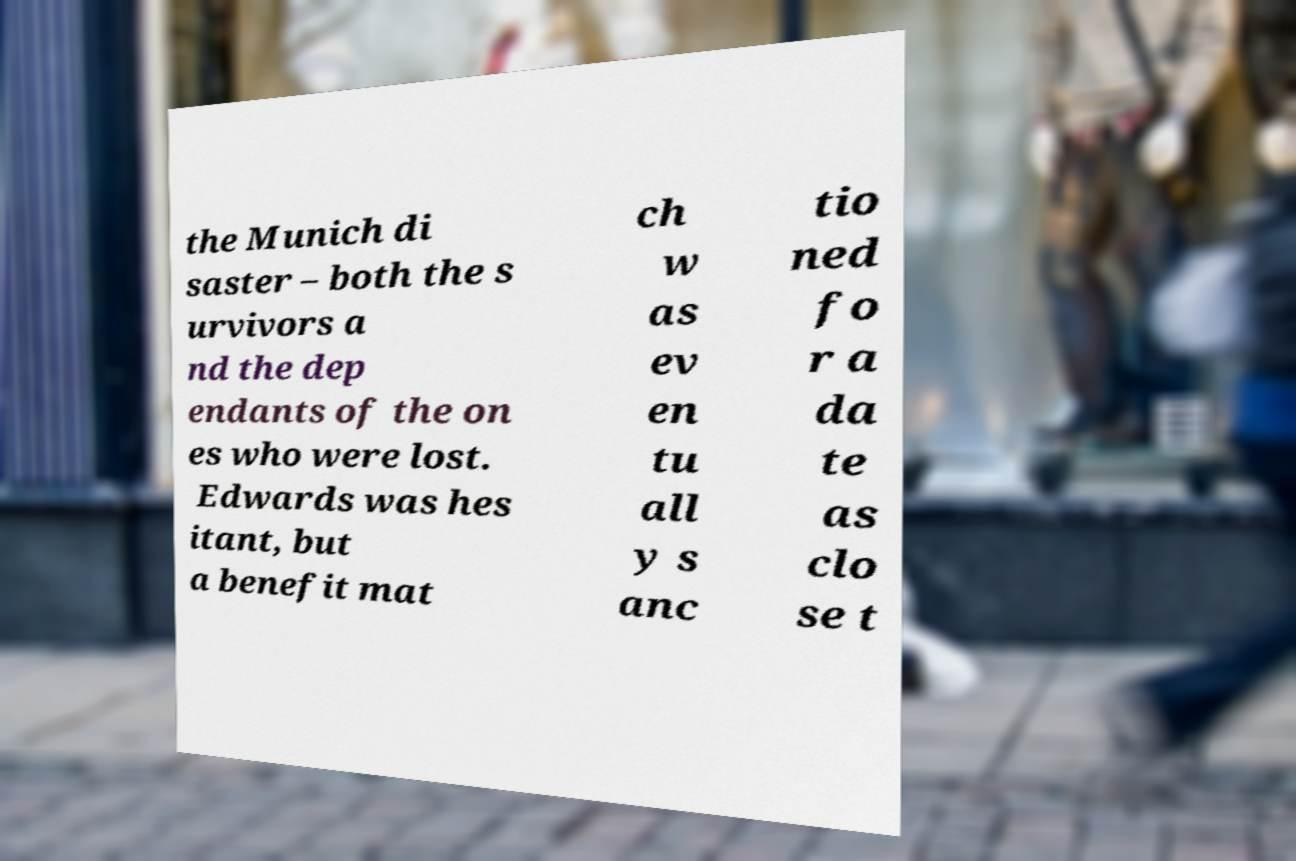What messages or text are displayed in this image? I need them in a readable, typed format. the Munich di saster – both the s urvivors a nd the dep endants of the on es who were lost. Edwards was hes itant, but a benefit mat ch w as ev en tu all y s anc tio ned fo r a da te as clo se t 